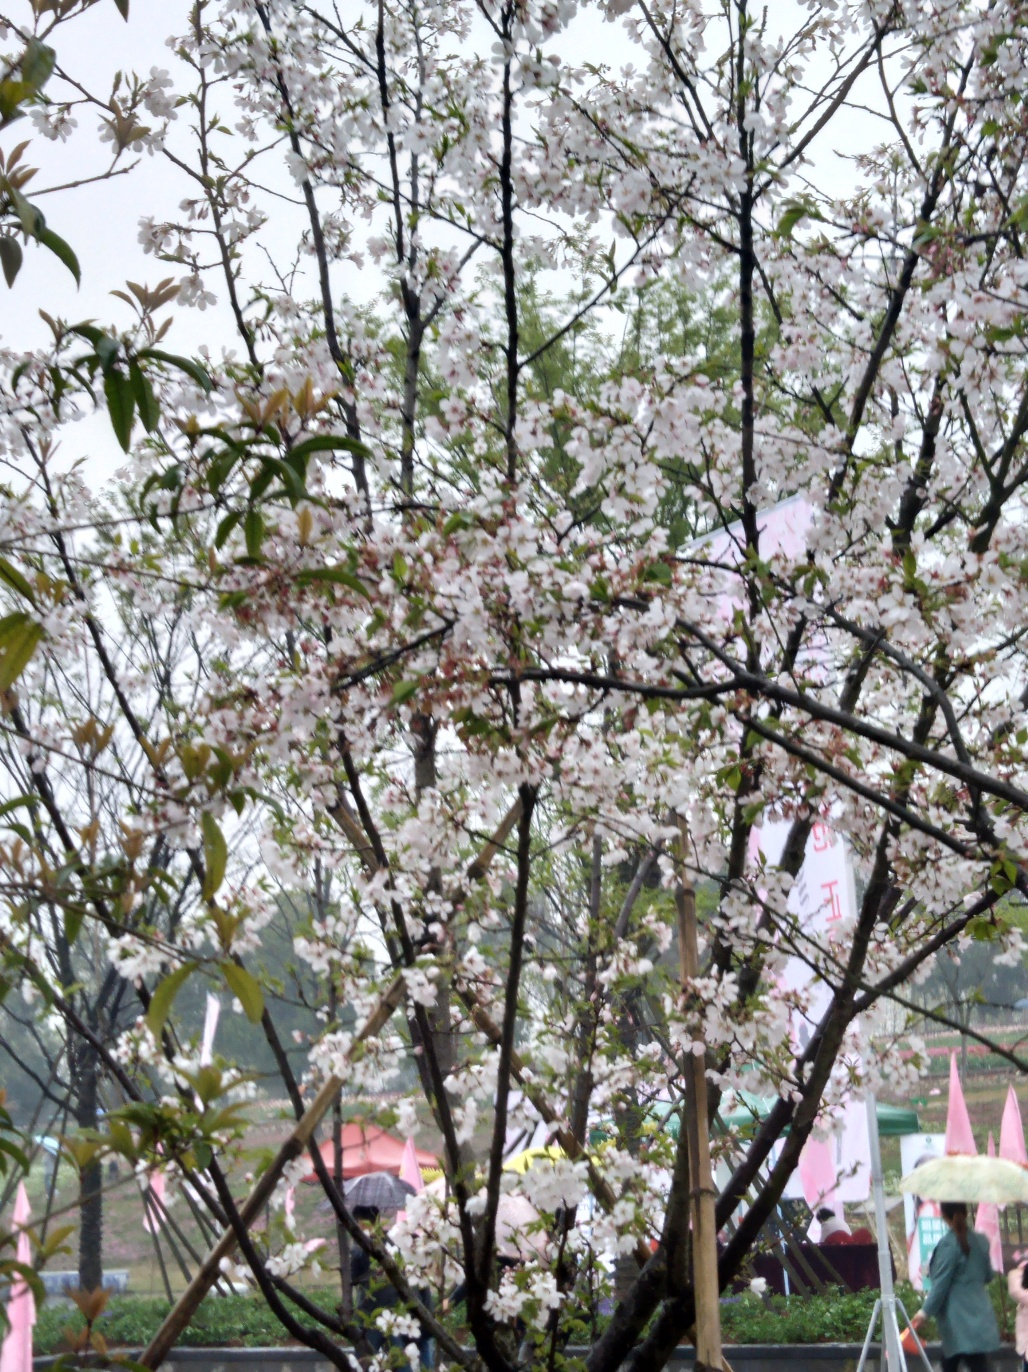What activities might people be engaging in within this setting? People in the image might be enjoying leisure activities such as walking, picnicking, or simply appreciating the blooming tree. The presence of umbrellas indicates that some are likely strolling through the area despite a light rain, possibly engaged in the traditional practice of 'hanami', which involves viewing and celebrating the transient beauty of flowers, commonly cherry blossoms. 